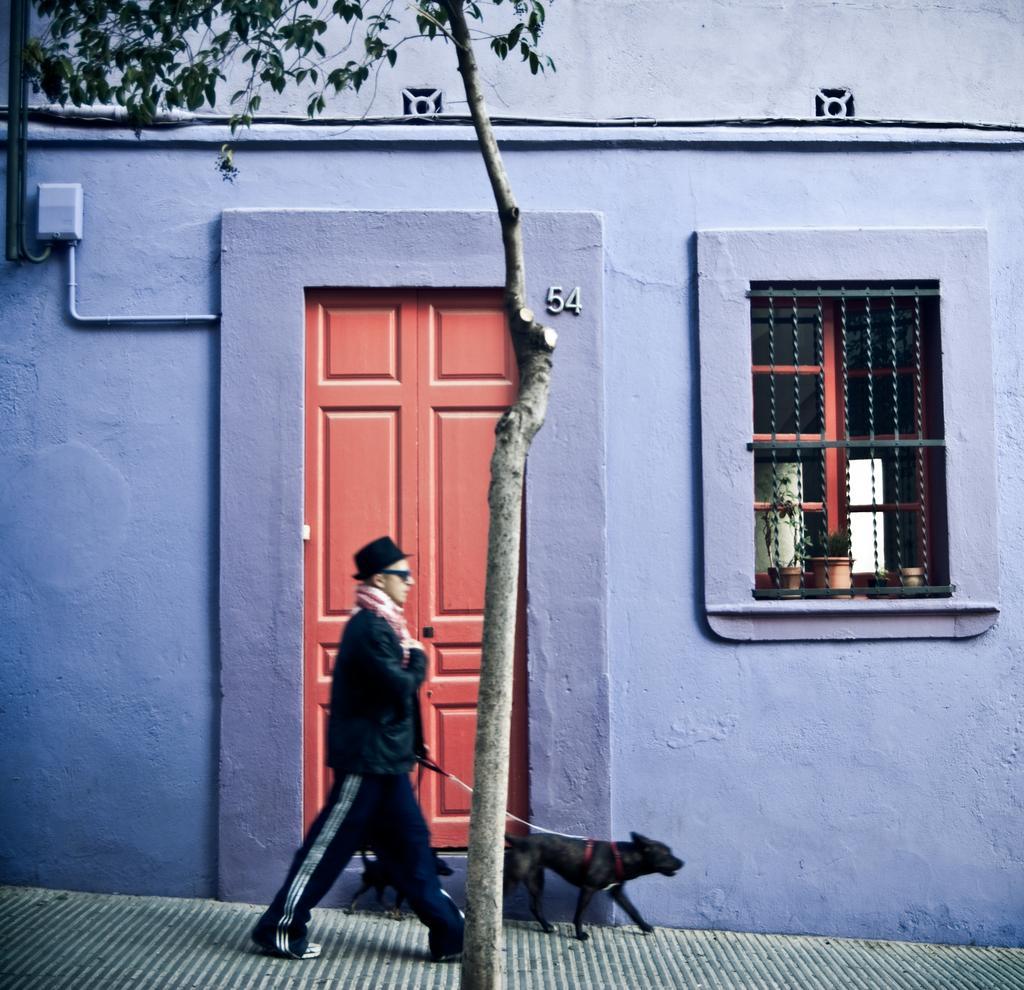Describe this image in one or two sentences. This is building with window and door. In-front of this window there are plants. This person is walking, as there is a leg movement. Beside this person there are dogs. 